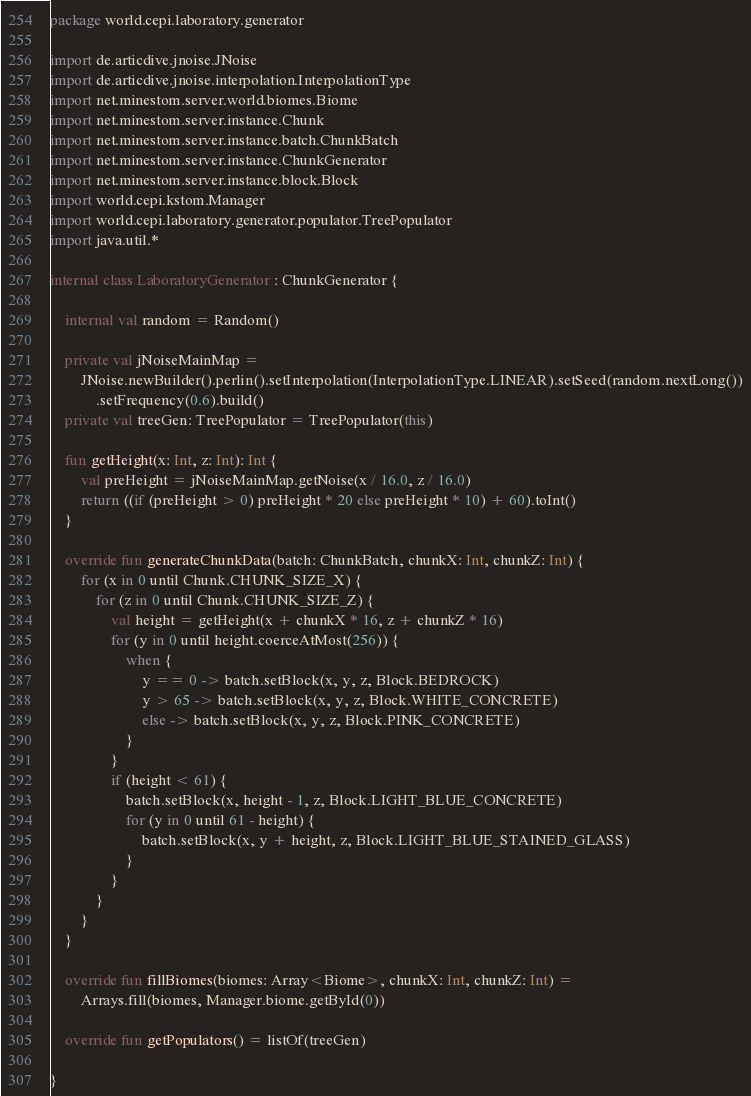<code> <loc_0><loc_0><loc_500><loc_500><_Kotlin_>package world.cepi.laboratory.generator

import de.articdive.jnoise.JNoise
import de.articdive.jnoise.interpolation.InterpolationType
import net.minestom.server.world.biomes.Biome
import net.minestom.server.instance.Chunk
import net.minestom.server.instance.batch.ChunkBatch
import net.minestom.server.instance.ChunkGenerator
import net.minestom.server.instance.block.Block
import world.cepi.kstom.Manager
import world.cepi.laboratory.generator.populator.TreePopulator
import java.util.*

internal class LaboratoryGenerator : ChunkGenerator {

    internal val random = Random()

    private val jNoiseMainMap =
        JNoise.newBuilder().perlin().setInterpolation(InterpolationType.LINEAR).setSeed(random.nextLong())
            .setFrequency(0.6).build()
    private val treeGen: TreePopulator = TreePopulator(this)

    fun getHeight(x: Int, z: Int): Int {
        val preHeight = jNoiseMainMap.getNoise(x / 16.0, z / 16.0)
        return ((if (preHeight > 0) preHeight * 20 else preHeight * 10) + 60).toInt()
    }

    override fun generateChunkData(batch: ChunkBatch, chunkX: Int, chunkZ: Int) {
        for (x in 0 until Chunk.CHUNK_SIZE_X) {
            for (z in 0 until Chunk.CHUNK_SIZE_Z) {
                val height = getHeight(x + chunkX * 16, z + chunkZ * 16)
                for (y in 0 until height.coerceAtMost(256)) {
                    when {
                        y == 0 -> batch.setBlock(x, y, z, Block.BEDROCK)
                        y > 65 -> batch.setBlock(x, y, z, Block.WHITE_CONCRETE)
                        else -> batch.setBlock(x, y, z, Block.PINK_CONCRETE)
                    }
                }
                if (height < 61) {
                    batch.setBlock(x, height - 1, z, Block.LIGHT_BLUE_CONCRETE)
                    for (y in 0 until 61 - height) {
                        batch.setBlock(x, y + height, z, Block.LIGHT_BLUE_STAINED_GLASS)
                    }
                }
            }
        }
    }

    override fun fillBiomes(biomes: Array<Biome>, chunkX: Int, chunkZ: Int) =
        Arrays.fill(biomes, Manager.biome.getById(0))

    override fun getPopulators() = listOf(treeGen)

}</code> 